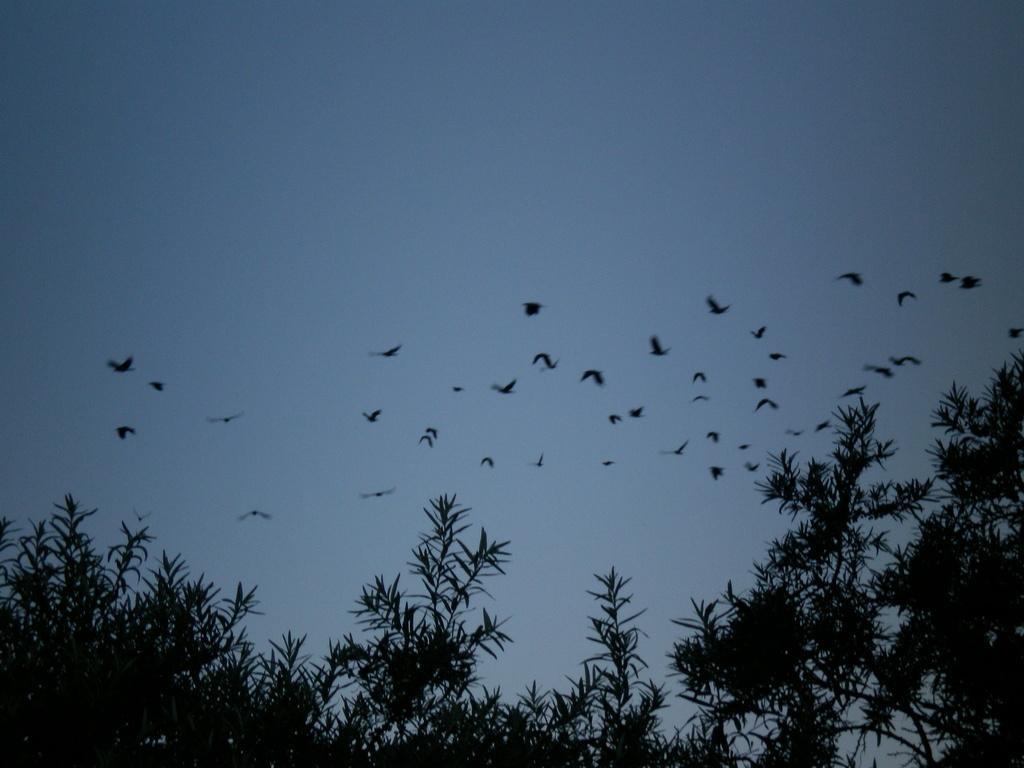Can you describe this image briefly? In the picture I can see the birds flying in the sky. I can see the trees at the bottom of the picture. There are clouds in the sky. 